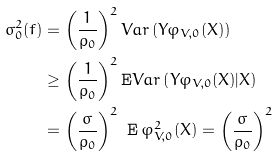Convert formula to latex. <formula><loc_0><loc_0><loc_500><loc_500>\sigma _ { 0 } ^ { 2 } ( f ) & = \left ( \frac { 1 } { \rho _ { 0 } } \right ) ^ { 2 } V a r \left ( Y \varphi _ { V , 0 } ( X ) \right ) \\ & \geq \left ( \frac { 1 } { \rho _ { 0 } } \right ) ^ { 2 } \mathbf E V a r \left ( Y \varphi _ { V , 0 } ( X ) | X \right ) \\ & = \left ( \frac { \sigma } { \rho _ { 0 } } \right ) ^ { 2 } \ \mathbf E \, \varphi _ { V , 0 } ^ { 2 } ( X ) = \left ( \frac { \sigma } { \rho _ { 0 } } \right ) ^ { 2 }</formula> 